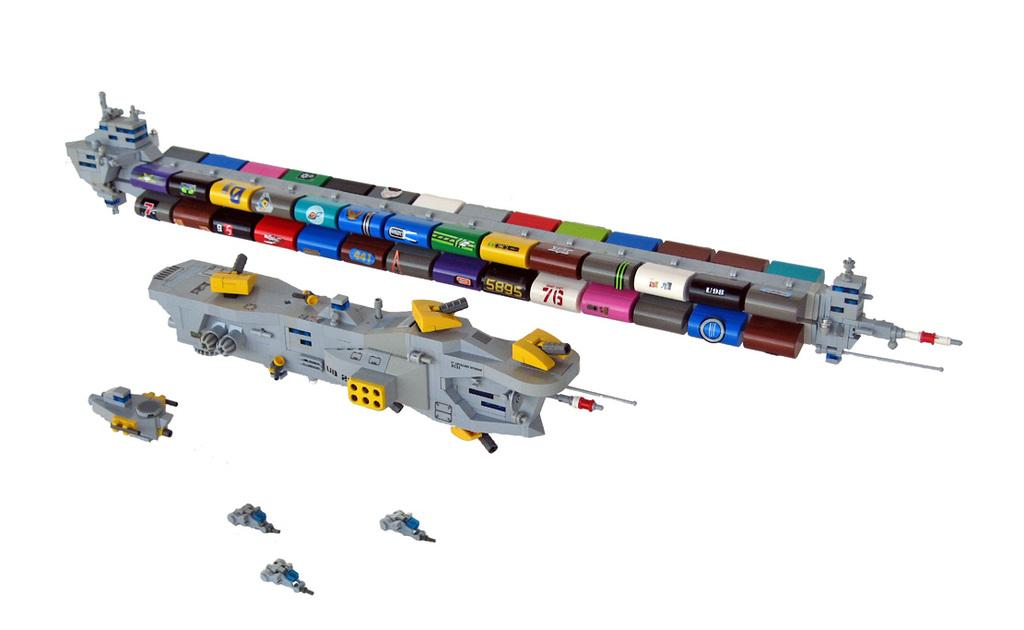What objects are present in the image? There are toys in the image. What is the color of the surface on which the toys are placed? The toys are on a white surface. Can you describe the appearance of the toys? The toys are colorful. How many cows are resting in the image? There are no cows present in the image. What type of stocking is visible on the toys in the image? There is no stocking present on the toys in the image. 